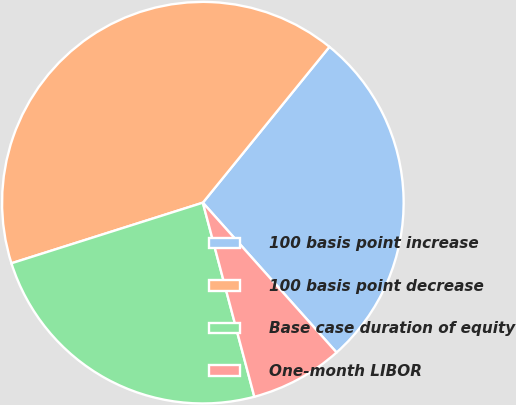Convert chart to OTSL. <chart><loc_0><loc_0><loc_500><loc_500><pie_chart><fcel>100 basis point increase<fcel>100 basis point decrease<fcel>Base case duration of equity<fcel>One-month LIBOR<nl><fcel>27.55%<fcel>40.74%<fcel>24.25%<fcel>7.47%<nl></chart> 